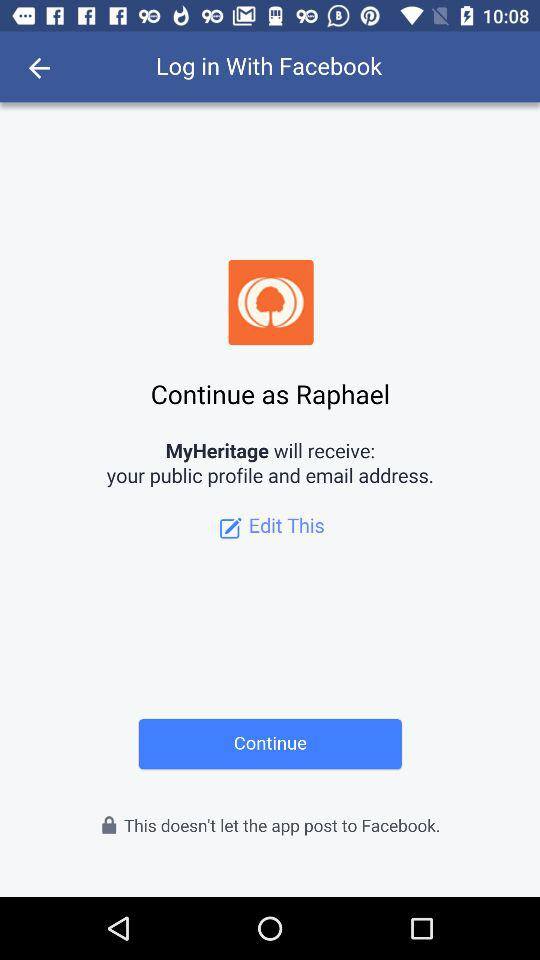What application is asking for permission? The application is "MyHeritage". 